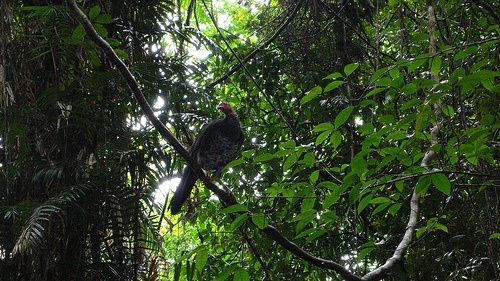Describe the objects in this image and their specific colors. I can see a bird in black, gray, and darkgreen tones in this image. 